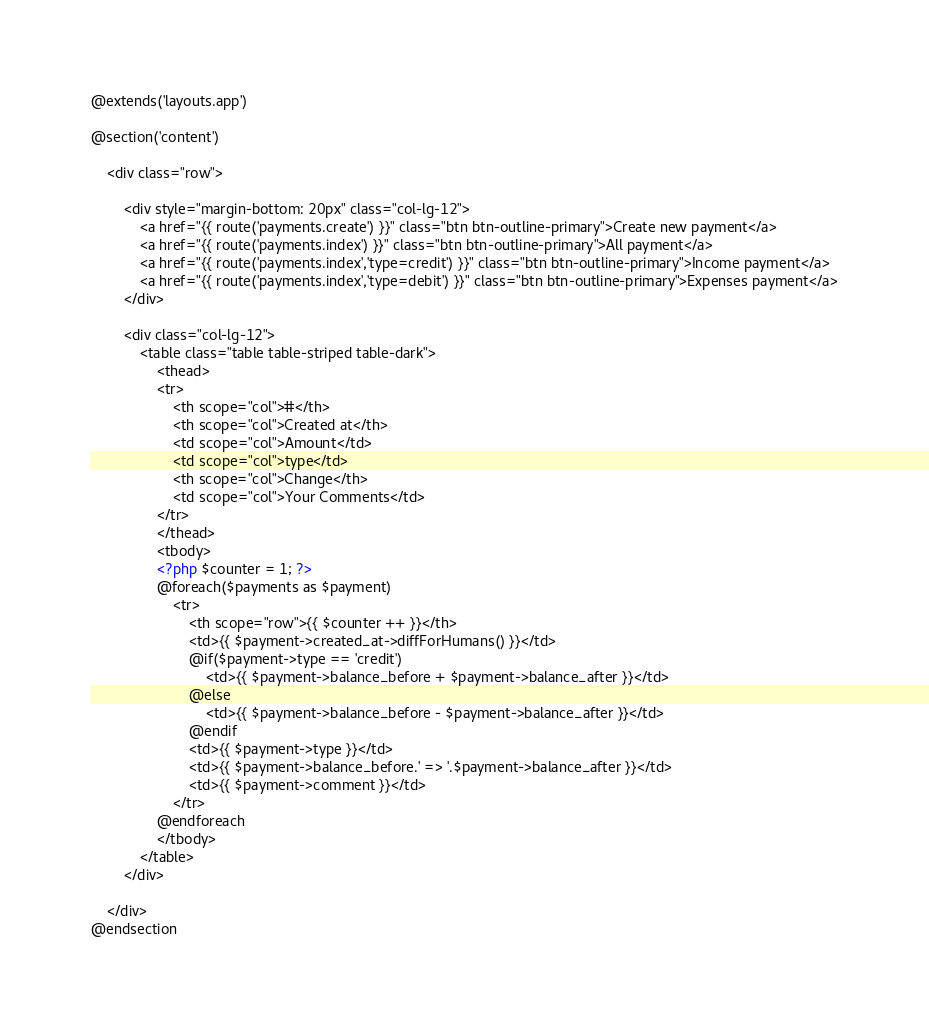Convert code to text. <code><loc_0><loc_0><loc_500><loc_500><_PHP_>@extends('layouts.app')

@section('content')

    <div class="row">

        <div style="margin-bottom: 20px" class="col-lg-12">
            <a href="{{ route('payments.create') }}" class="btn btn-outline-primary">Create new payment</a>
            <a href="{{ route('payments.index') }}" class="btn btn-outline-primary">All payment</a>
            <a href="{{ route('payments.index','type=credit') }}" class="btn btn-outline-primary">Income payment</a>
            <a href="{{ route('payments.index','type=debit') }}" class="btn btn-outline-primary">Expenses payment</a>
        </div>

        <div class="col-lg-12">
            <table class="table table-striped table-dark">
                <thead>
                <tr>
                    <th scope="col">#</th>
                    <th scope="col">Created at</th>
                    <td scope="col">Amount</td>
                    <td scope="col">type</td>
                    <th scope="col">Change</th>
                    <td scope="col">Your Comments</td>
                </tr>
                </thead>
                <tbody>
                <?php $counter = 1; ?>
                @foreach($payments as $payment)
                    <tr>
                        <th scope="row">{{ $counter ++ }}</th>
                        <td>{{ $payment->created_at->diffForHumans() }}</td>
                        @if($payment->type == 'credit')
                            <td>{{ $payment->balance_before + $payment->balance_after }}</td>
                        @else
                            <td>{{ $payment->balance_before - $payment->balance_after }}</td>
                        @endif
                        <td>{{ $payment->type }}</td>
                        <td>{{ $payment->balance_before.' => '.$payment->balance_after }}</td>
                        <td>{{ $payment->comment }}</td>
                    </tr>
                @endforeach
                </tbody>
            </table>
        </div>

    </div>
@endsection</code> 